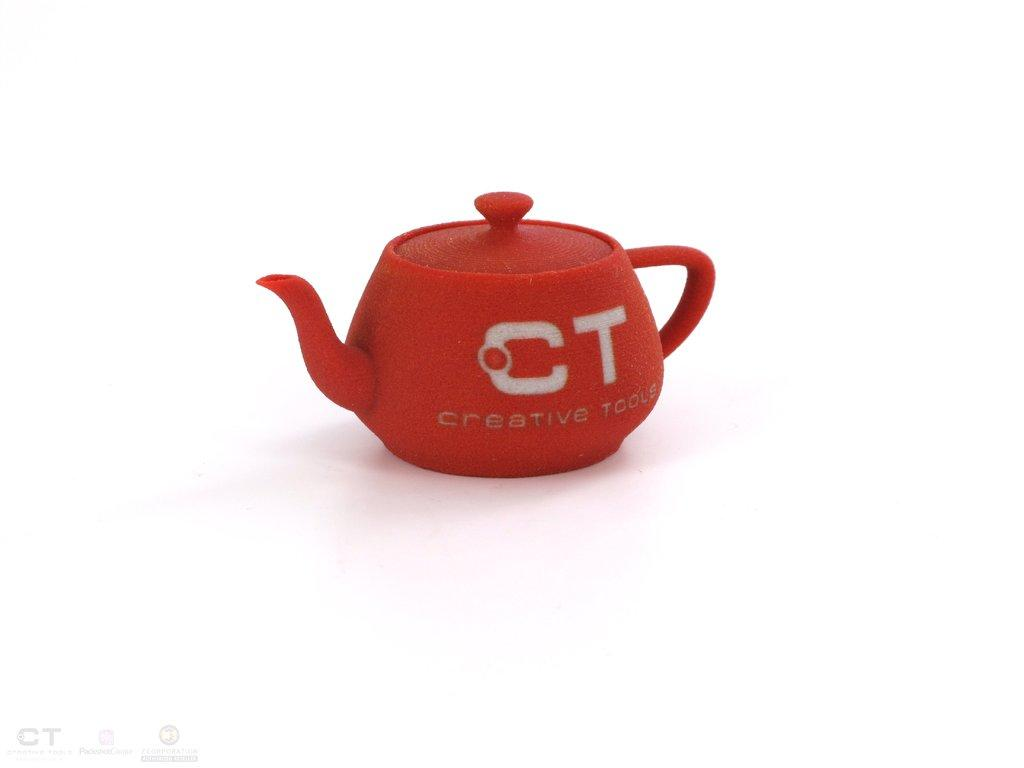What is placed on a surface in the image? There is a kettle placed on a surface in the image. Can you describe any additional details about the kettle? Unfortunately, no additional details about the kettle are provided in the facts. What can be seen at the bottom of the image? There are logos visible at the bottom of the image. Can you describe the taste of the person in the image? There is no person present in the image, so it is not possible to describe the taste of a person. What type of horse can be seen in the image? There is no horse present in the image. 